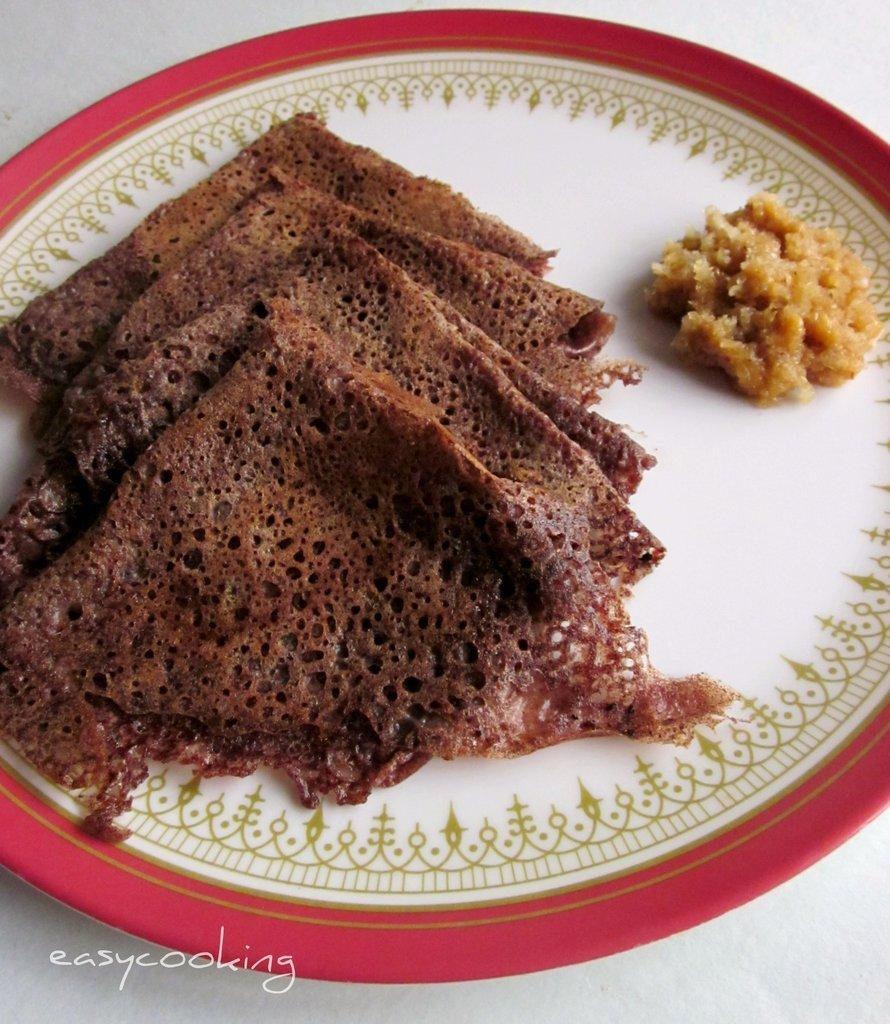What is on the plate that is visible in the image? There is food on the plate in the image. What is the color of the surface on which the plate is placed? The plate is on a white surface. Is there any additional information about the image that is not related to the plate or food? Yes, there is a watermark in the bottom left corner of the image. How many daughters are visible in the image? There are no daughters present in the image. What type of horse can be seen grazing on the mountain in the image? There is no horse or mountain present in the image. 